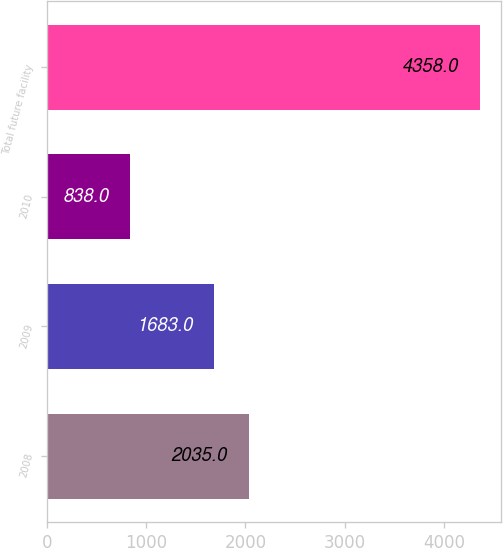Convert chart to OTSL. <chart><loc_0><loc_0><loc_500><loc_500><bar_chart><fcel>2008<fcel>2009<fcel>2010<fcel>Total future facility<nl><fcel>2035<fcel>1683<fcel>838<fcel>4358<nl></chart> 